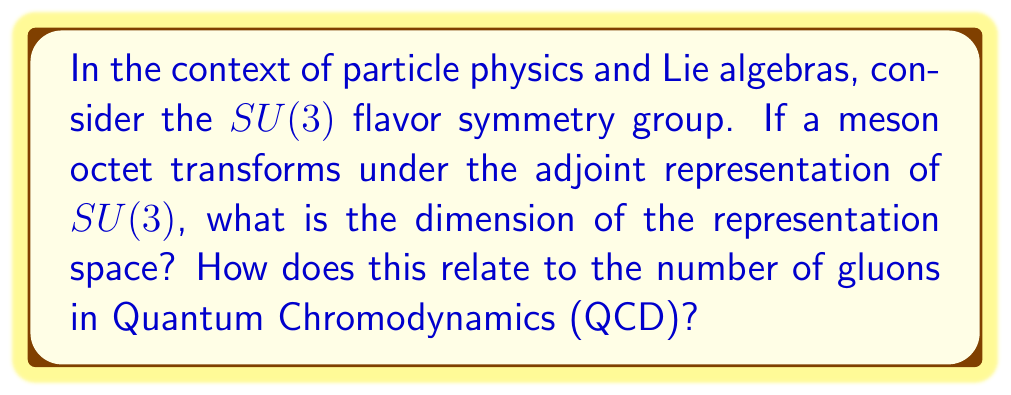What is the answer to this math problem? To solve this problem, we'll follow these steps:

1) First, recall that $SU(3)$ is the special unitary group of degree 3, which is a Lie group.

2) The dimension of the adjoint representation of a Lie group is equal to the dimension of its Lie algebra.

3) For $SU(n)$, the dimension of the Lie algebra is given by $n^2 - 1$.

4) In this case, $n = 3$, so the dimension of the representation space is:

   $$ 3^2 - 1 = 9 - 1 = 8 $$

5) This result is significant in particle physics, particularly in QCD:

   - The 8-dimensional representation corresponds to the meson octet in the quark model.
   - It also corresponds to the number of gluons in QCD.

6) Gluons are the force carriers of the strong interaction in QCD and come in 8 color-anticolor combinations, which transform as the adjoint representation of $SU(3)$.

This connection between representation theory and particle physics demonstrates how mathematical structures can predict or explain physical phenomena, highlighting the potential for cross-disciplinary collaborations between mathematicians and physicists.
Answer: 8 